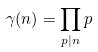Convert formula to latex. <formula><loc_0><loc_0><loc_500><loc_500>\gamma ( n ) = \prod _ { p | n } p</formula> 